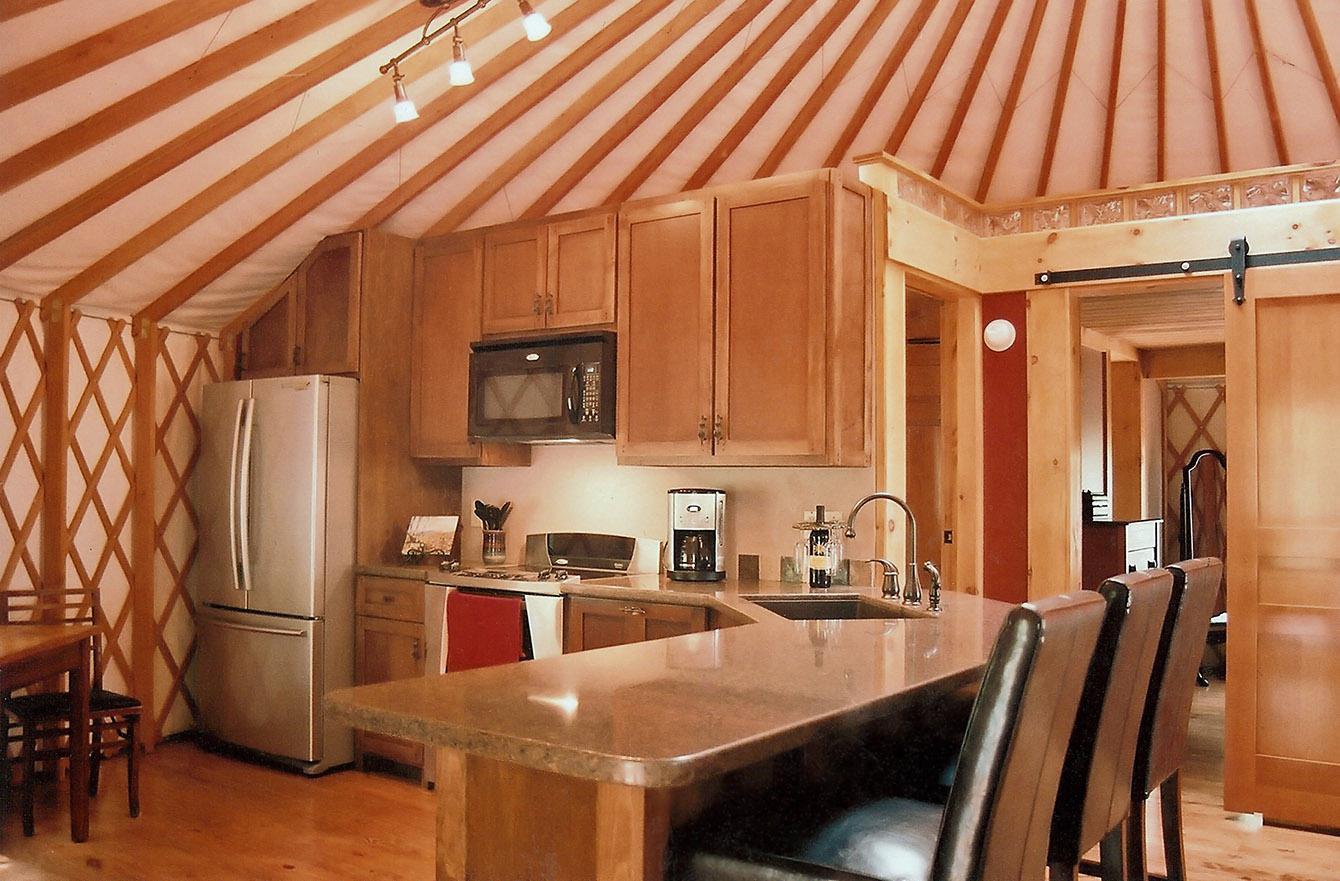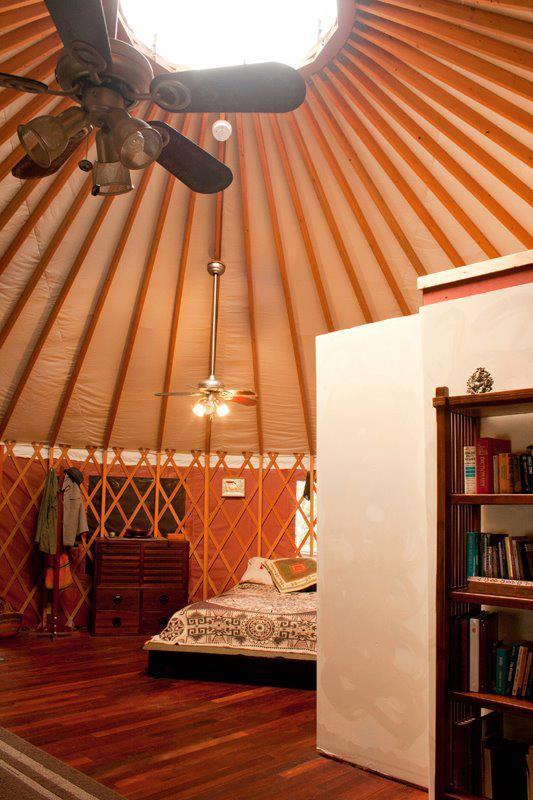The first image is the image on the left, the second image is the image on the right. For the images displayed, is the sentence "The refridgerator is set up near the wall of a tent." factually correct? Answer yes or no. Yes. The first image is the image on the left, the second image is the image on the right. Given the left and right images, does the statement "In one image, a stainless steel refrigerator is in the kitchen area of a yurt, while a second image shows a bedroom area." hold true? Answer yes or no. Yes. 